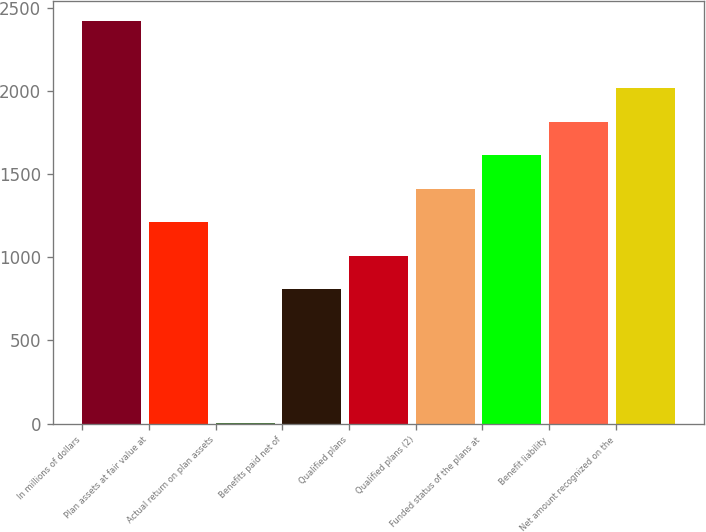Convert chart. <chart><loc_0><loc_0><loc_500><loc_500><bar_chart><fcel>In millions of dollars<fcel>Plan assets at fair value at<fcel>Actual return on plan assets<fcel>Benefits paid net of<fcel>Qualified plans<fcel>Qualified plans (2)<fcel>Funded status of the plans at<fcel>Benefit liability<fcel>Net amount recognized on the<nl><fcel>2417.8<fcel>1209.4<fcel>1<fcel>806.6<fcel>1008<fcel>1410.8<fcel>1612.2<fcel>1813.6<fcel>2015<nl></chart> 